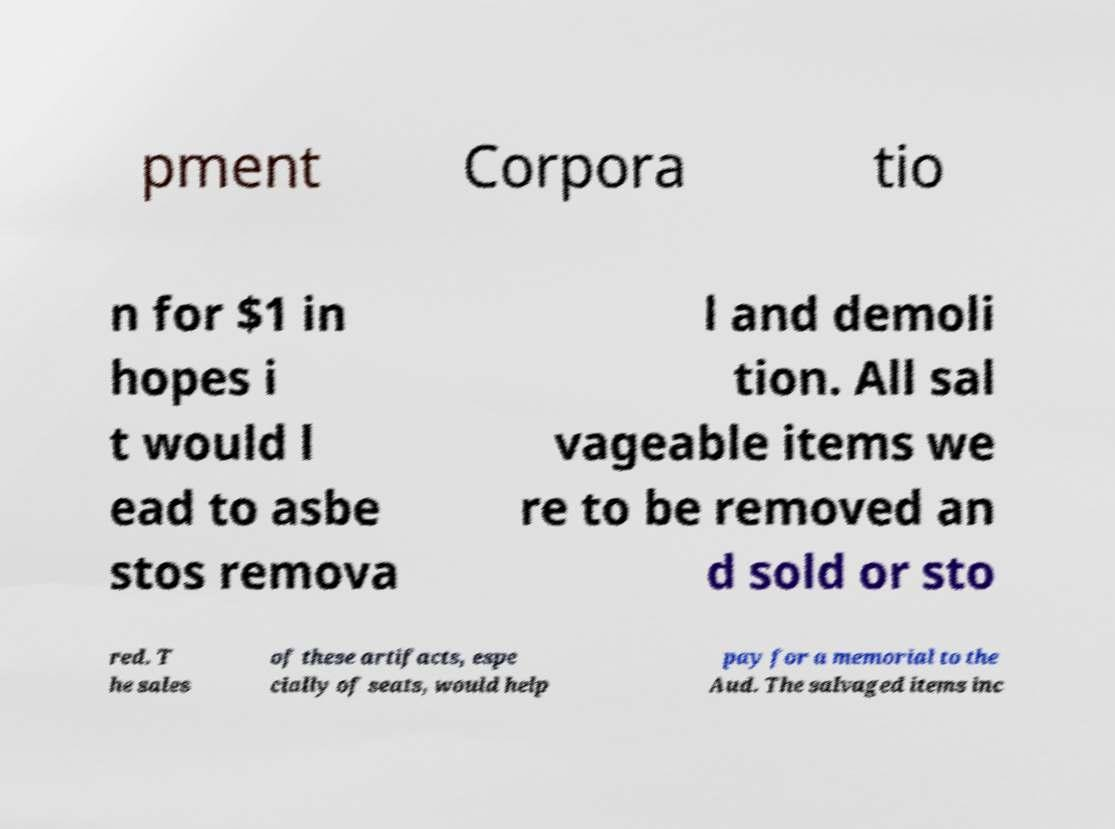I need the written content from this picture converted into text. Can you do that? pment Corpora tio n for $1 in hopes i t would l ead to asbe stos remova l and demoli tion. All sal vageable items we re to be removed an d sold or sto red. T he sales of these artifacts, espe cially of seats, would help pay for a memorial to the Aud. The salvaged items inc 